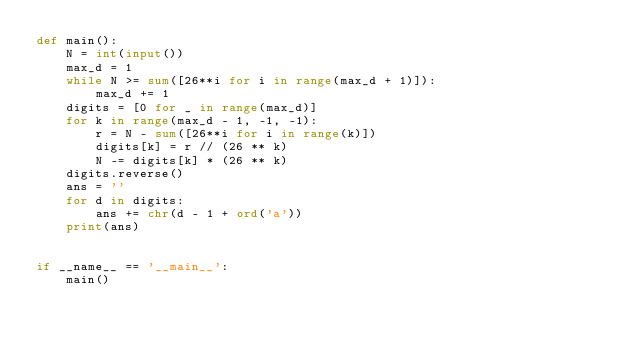<code> <loc_0><loc_0><loc_500><loc_500><_Python_>def main():
    N = int(input())
    max_d = 1
    while N >= sum([26**i for i in range(max_d + 1)]):
        max_d += 1
    digits = [0 for _ in range(max_d)]
    for k in range(max_d - 1, -1, -1):
        r = N - sum([26**i for i in range(k)])
        digits[k] = r // (26 ** k)
        N -= digits[k] * (26 ** k)
    digits.reverse()
    ans = ''
    for d in digits:
        ans += chr(d - 1 + ord('a'))
    print(ans)


if __name__ == '__main__':
    main()</code> 